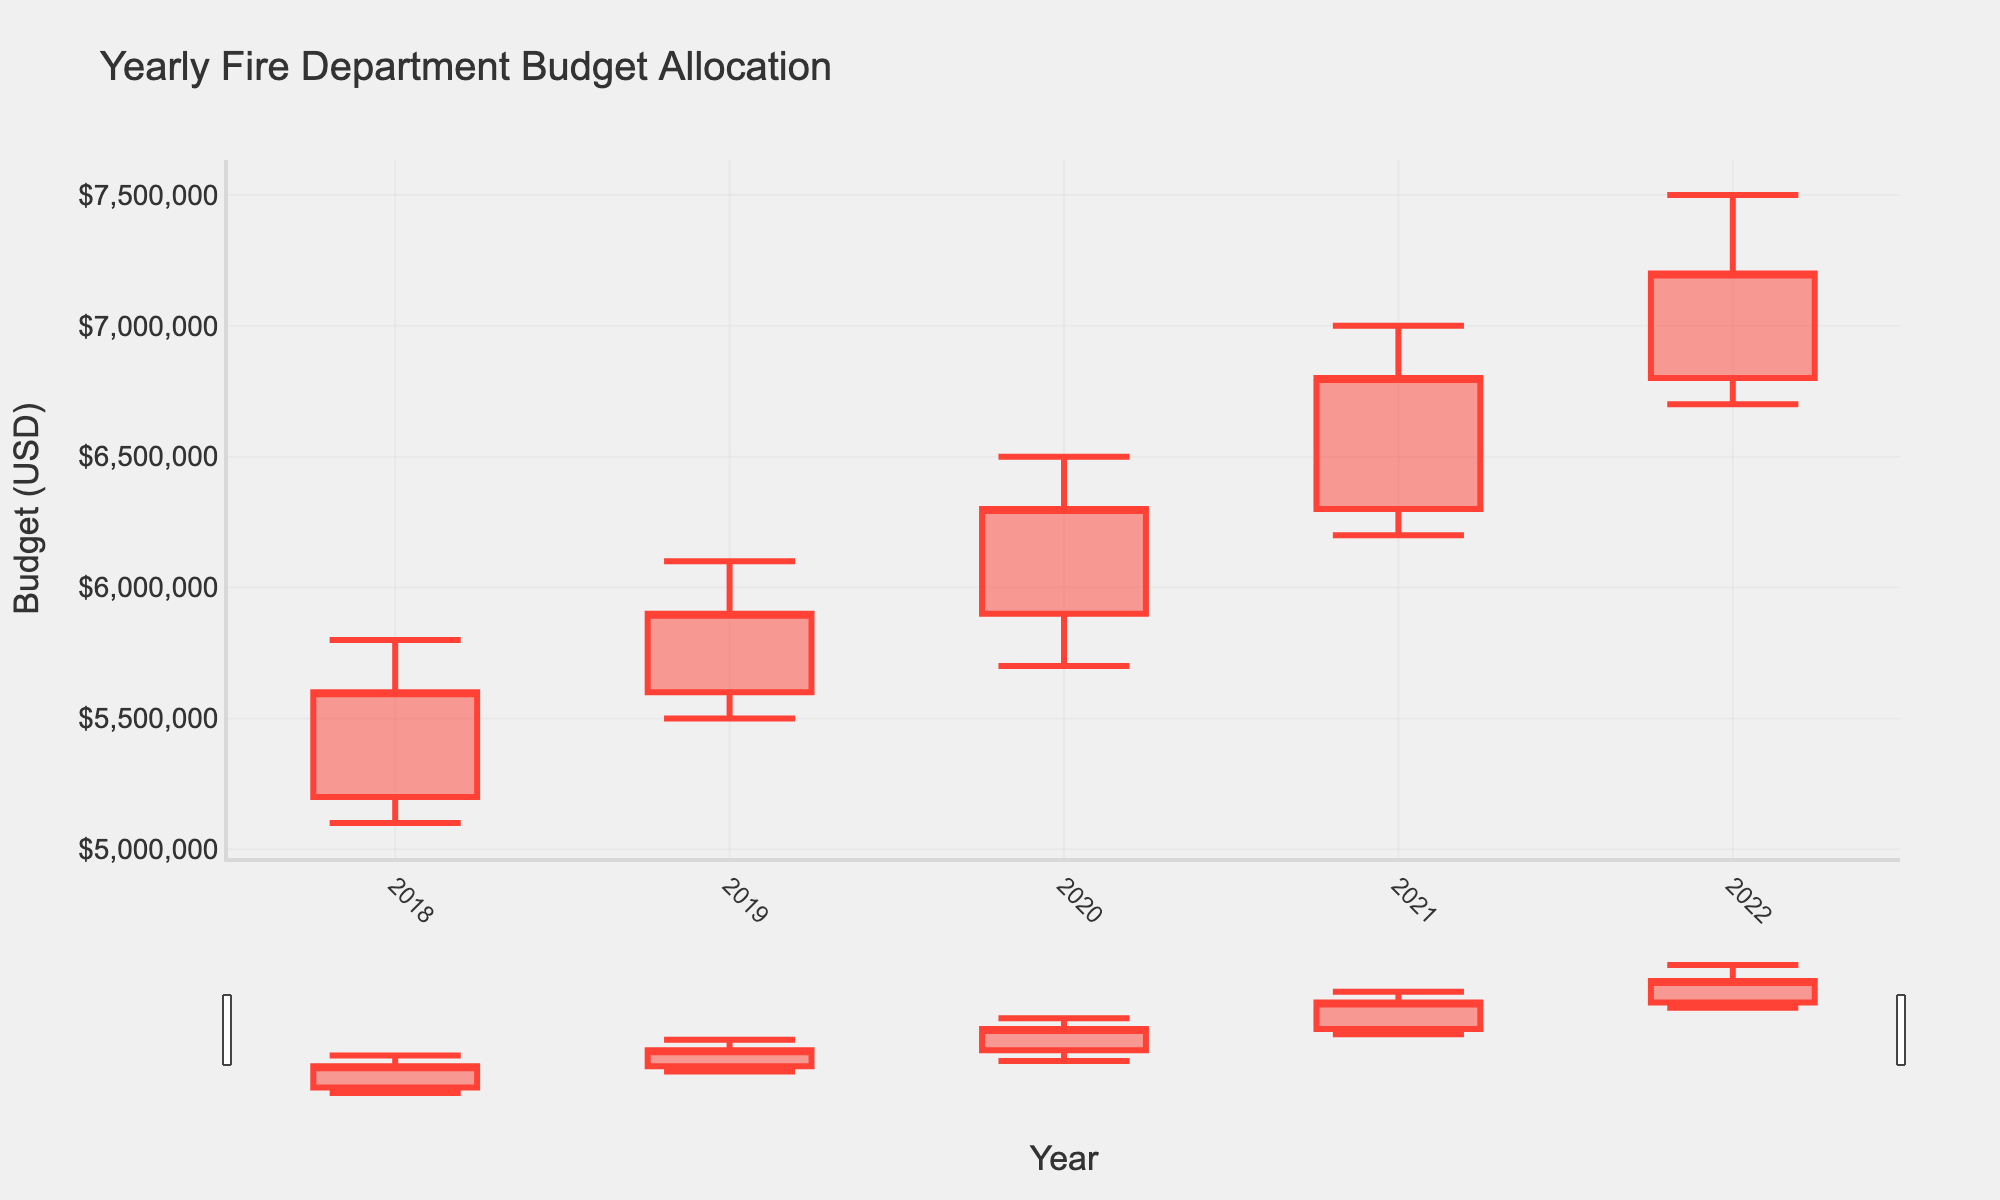What is the title of the chart? The title of the chart is displayed prominently at the top of the chart, showing "Yearly Fire Department Budget Allocation".
Answer: Yearly Fire Department Budget Allocation What are the x-axis and y-axis titles in the chart? The x-axis title, representing the horizontal scale, is labeled "Year". The y-axis title, representing the vertical scale, is labeled "Budget (USD)".
Answer: Year (x-axis), Budget (USD) (y-axis) How did the initial allocation value change from 2021 to 2022? The initial allocation value in 2021 was $6,300,000, and it increased to $6,800,000 in 2022. By subtracting $6,300,000 from $6,800,000, we get an increase of $500,000.
Answer: Increased by $500,000 In which year did the highest budget allocation occur? To find the year with the highest budget allocation, we compare the "Highest" values for each year. The highest budget allocation is found in 2022, with $7,500,000.
Answer: 2022 Which year had the lowest final budget allocation? The final budget allocations for each year can be compared to determine which year had the lowest. In this case, 2018 had the lowest final budget allocation of $5,600,000.
Answer: 2018 What is the difference between the highest and lowest budget allocations in 2020? In 2020, the highest allocation was $6,500,000 and the lowest was $5,700,000. Subtracting the lowest from the highest gives: $6,500,000 - $5,700,000 = $800,000.
Answer: $800,000 How many years are represented in the chart? The x-axis tick marks represent the years from 2018 to 2022, inclusive. By counting these years, we find there are 5 years represented.
Answer: 5 years Comparing 2019 and 2020, which year had a larger increase from initial to final budget allocation? The increase from initial to final allocation in 2019 is $5,900,000 - $5,600,000 = $300,000. In 2020, it is $6,300,000 - $5,900,000 = $400,000. Therefore, 2020 had a larger increase.
Answer: 2020 Which year saw the smallest range between the highest and lowest budget allocations? To find the year with the smallest range, we calculate the difference between the highest and lowest allocations for each year and compare: 2018: $6,300,000 - $5,100,000 = $200,000, 2019: $6,100,000 - $5,500,000 = $600,000, 2020: $6,500,000 - $5,700,000 = $800,000, 2021: $7,000,000 - $6,200,000 = $800,000, 2022: $7,500,000 - $6,700,000 = $800,000. The smallest range is $500,000 in 2018.
Answer: 2018 